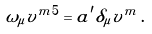Convert formula to latex. <formula><loc_0><loc_0><loc_500><loc_500>\omega _ { \mu } v ^ { m 5 } = a ^ { \prime } \delta _ { \mu } v ^ { m } \, .</formula> 